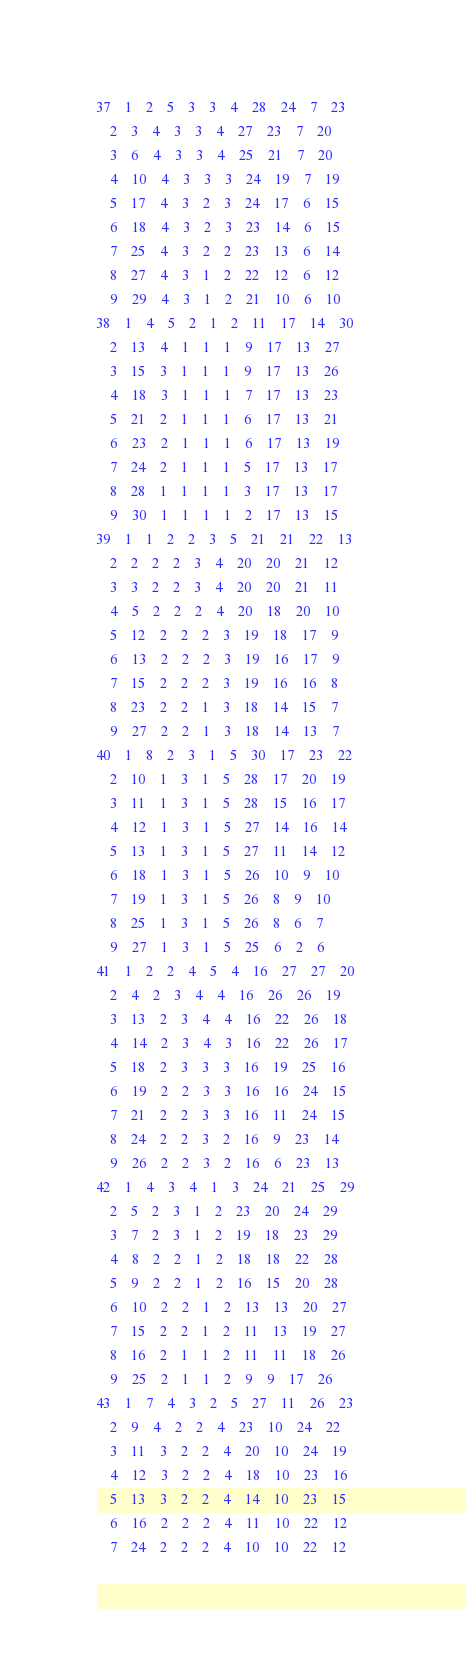<code> <loc_0><loc_0><loc_500><loc_500><_ObjectiveC_>37	1	2	5	3	3	4	28	24	7	23	
	2	3	4	3	3	4	27	23	7	20	
	3	6	4	3	3	4	25	21	7	20	
	4	10	4	3	3	3	24	19	7	19	
	5	17	4	3	2	3	24	17	6	15	
	6	18	4	3	2	3	23	14	6	15	
	7	25	4	3	2	2	23	13	6	14	
	8	27	4	3	1	2	22	12	6	12	
	9	29	4	3	1	2	21	10	6	10	
38	1	4	5	2	1	2	11	17	14	30	
	2	13	4	1	1	1	9	17	13	27	
	3	15	3	1	1	1	9	17	13	26	
	4	18	3	1	1	1	7	17	13	23	
	5	21	2	1	1	1	6	17	13	21	
	6	23	2	1	1	1	6	17	13	19	
	7	24	2	1	1	1	5	17	13	17	
	8	28	1	1	1	1	3	17	13	17	
	9	30	1	1	1	1	2	17	13	15	
39	1	1	2	2	3	5	21	21	22	13	
	2	2	2	2	3	4	20	20	21	12	
	3	3	2	2	3	4	20	20	21	11	
	4	5	2	2	2	4	20	18	20	10	
	5	12	2	2	2	3	19	18	17	9	
	6	13	2	2	2	3	19	16	17	9	
	7	15	2	2	2	3	19	16	16	8	
	8	23	2	2	1	3	18	14	15	7	
	9	27	2	2	1	3	18	14	13	7	
40	1	8	2	3	1	5	30	17	23	22	
	2	10	1	3	1	5	28	17	20	19	
	3	11	1	3	1	5	28	15	16	17	
	4	12	1	3	1	5	27	14	16	14	
	5	13	1	3	1	5	27	11	14	12	
	6	18	1	3	1	5	26	10	9	10	
	7	19	1	3	1	5	26	8	9	10	
	8	25	1	3	1	5	26	8	6	7	
	9	27	1	3	1	5	25	6	2	6	
41	1	2	2	4	5	4	16	27	27	20	
	2	4	2	3	4	4	16	26	26	19	
	3	13	2	3	4	4	16	22	26	18	
	4	14	2	3	4	3	16	22	26	17	
	5	18	2	3	3	3	16	19	25	16	
	6	19	2	2	3	3	16	16	24	15	
	7	21	2	2	3	3	16	11	24	15	
	8	24	2	2	3	2	16	9	23	14	
	9	26	2	2	3	2	16	6	23	13	
42	1	4	3	4	1	3	24	21	25	29	
	2	5	2	3	1	2	23	20	24	29	
	3	7	2	3	1	2	19	18	23	29	
	4	8	2	2	1	2	18	18	22	28	
	5	9	2	2	1	2	16	15	20	28	
	6	10	2	2	1	2	13	13	20	27	
	7	15	2	2	1	2	11	13	19	27	
	8	16	2	1	1	2	11	11	18	26	
	9	25	2	1	1	2	9	9	17	26	
43	1	7	4	3	2	5	27	11	26	23	
	2	9	4	2	2	4	23	10	24	22	
	3	11	3	2	2	4	20	10	24	19	
	4	12	3	2	2	4	18	10	23	16	
	5	13	3	2	2	4	14	10	23	15	
	6	16	2	2	2	4	11	10	22	12	
	7	24	2	2	2	4	10	10	22	12	</code> 